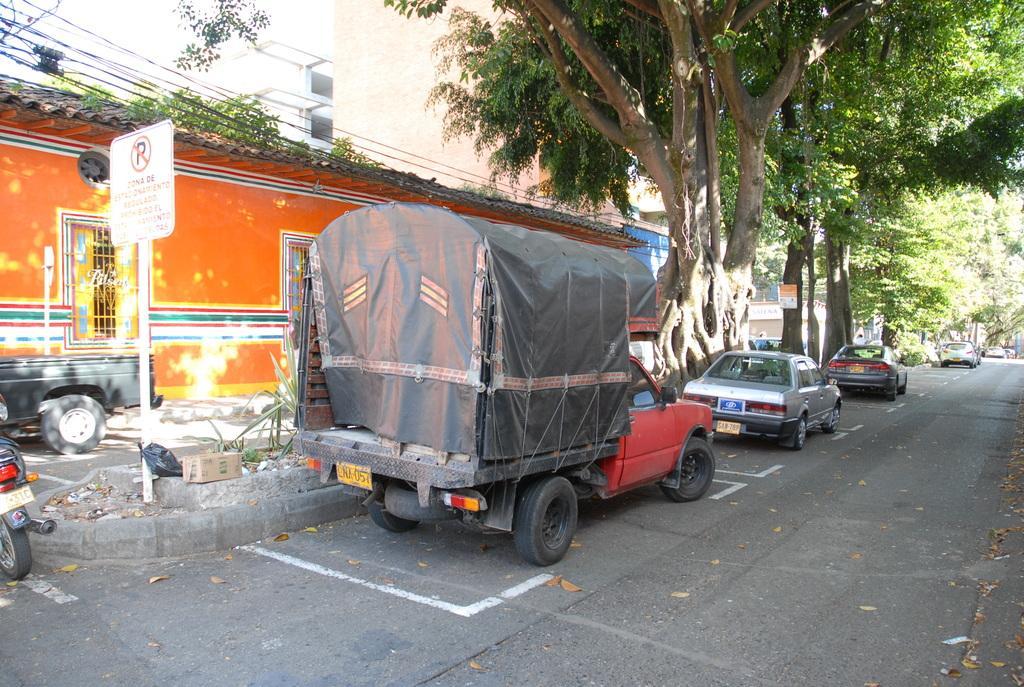In one or two sentences, can you explain what this image depicts? In this image I can see a road in the centre and on it I can see number of vehicles. On the left side of this image I can see a white colour board and near it I can see a box. I can also see something is written on the board. In the background I can see number of trees, few buildings, free wires and few more boards. 